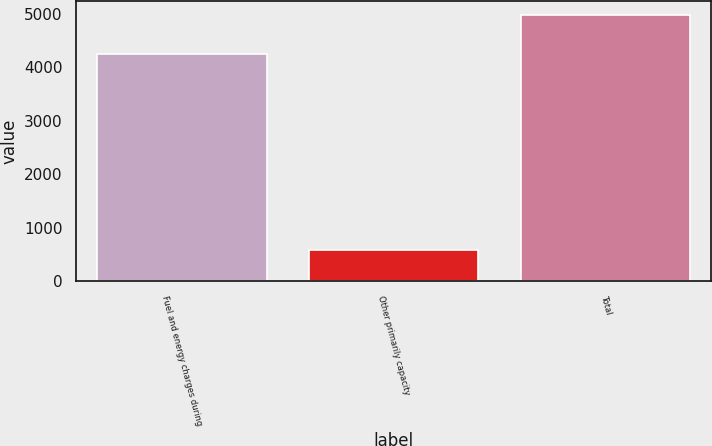Convert chart. <chart><loc_0><loc_0><loc_500><loc_500><bar_chart><fcel>Fuel and energy charges during<fcel>Other primarily capacity<fcel>Total<nl><fcel>4237<fcel>581<fcel>4977<nl></chart> 